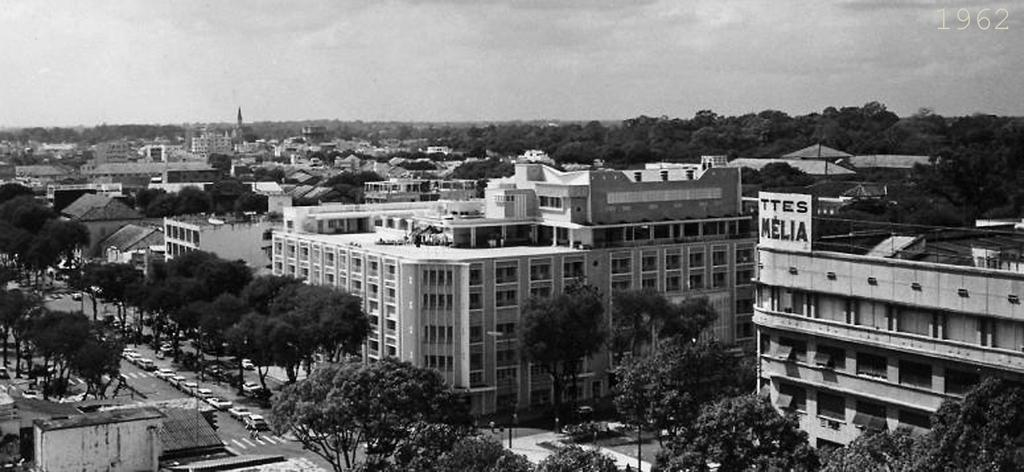What is the color scheme of the image? The image is black and white. What type of natural elements can be seen in the image? There are many trees in the image. What type of man-made structures are present in the image? There are buildings in the image. What type of transportation can be seen on the left side of the image? There are cars on the road on the left side of the image. What is visible at the top of the image? The sky is visible at the top of the image. How many friends are sitting on the fifth tree in the image? There is no mention of friends or a fifth tree in the image; it features trees, buildings, cars, and a black and white color scheme. 